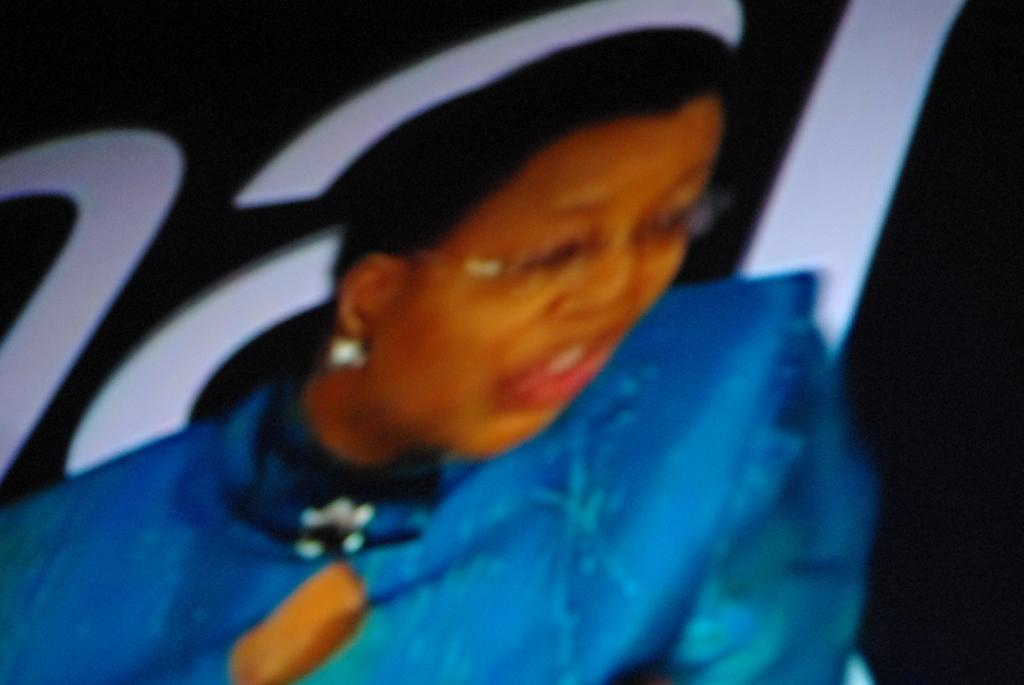What is the main subject of the image? There is a person in the image. Are there any words or letters in the image? Yes, there is text in the image. What can be observed about the overall appearance of the image? The background of the image is dark. Where is the nest located in the image? There is no nest present in the image. What type of dolls can be seen in the image? There are no dolls present in the image. 